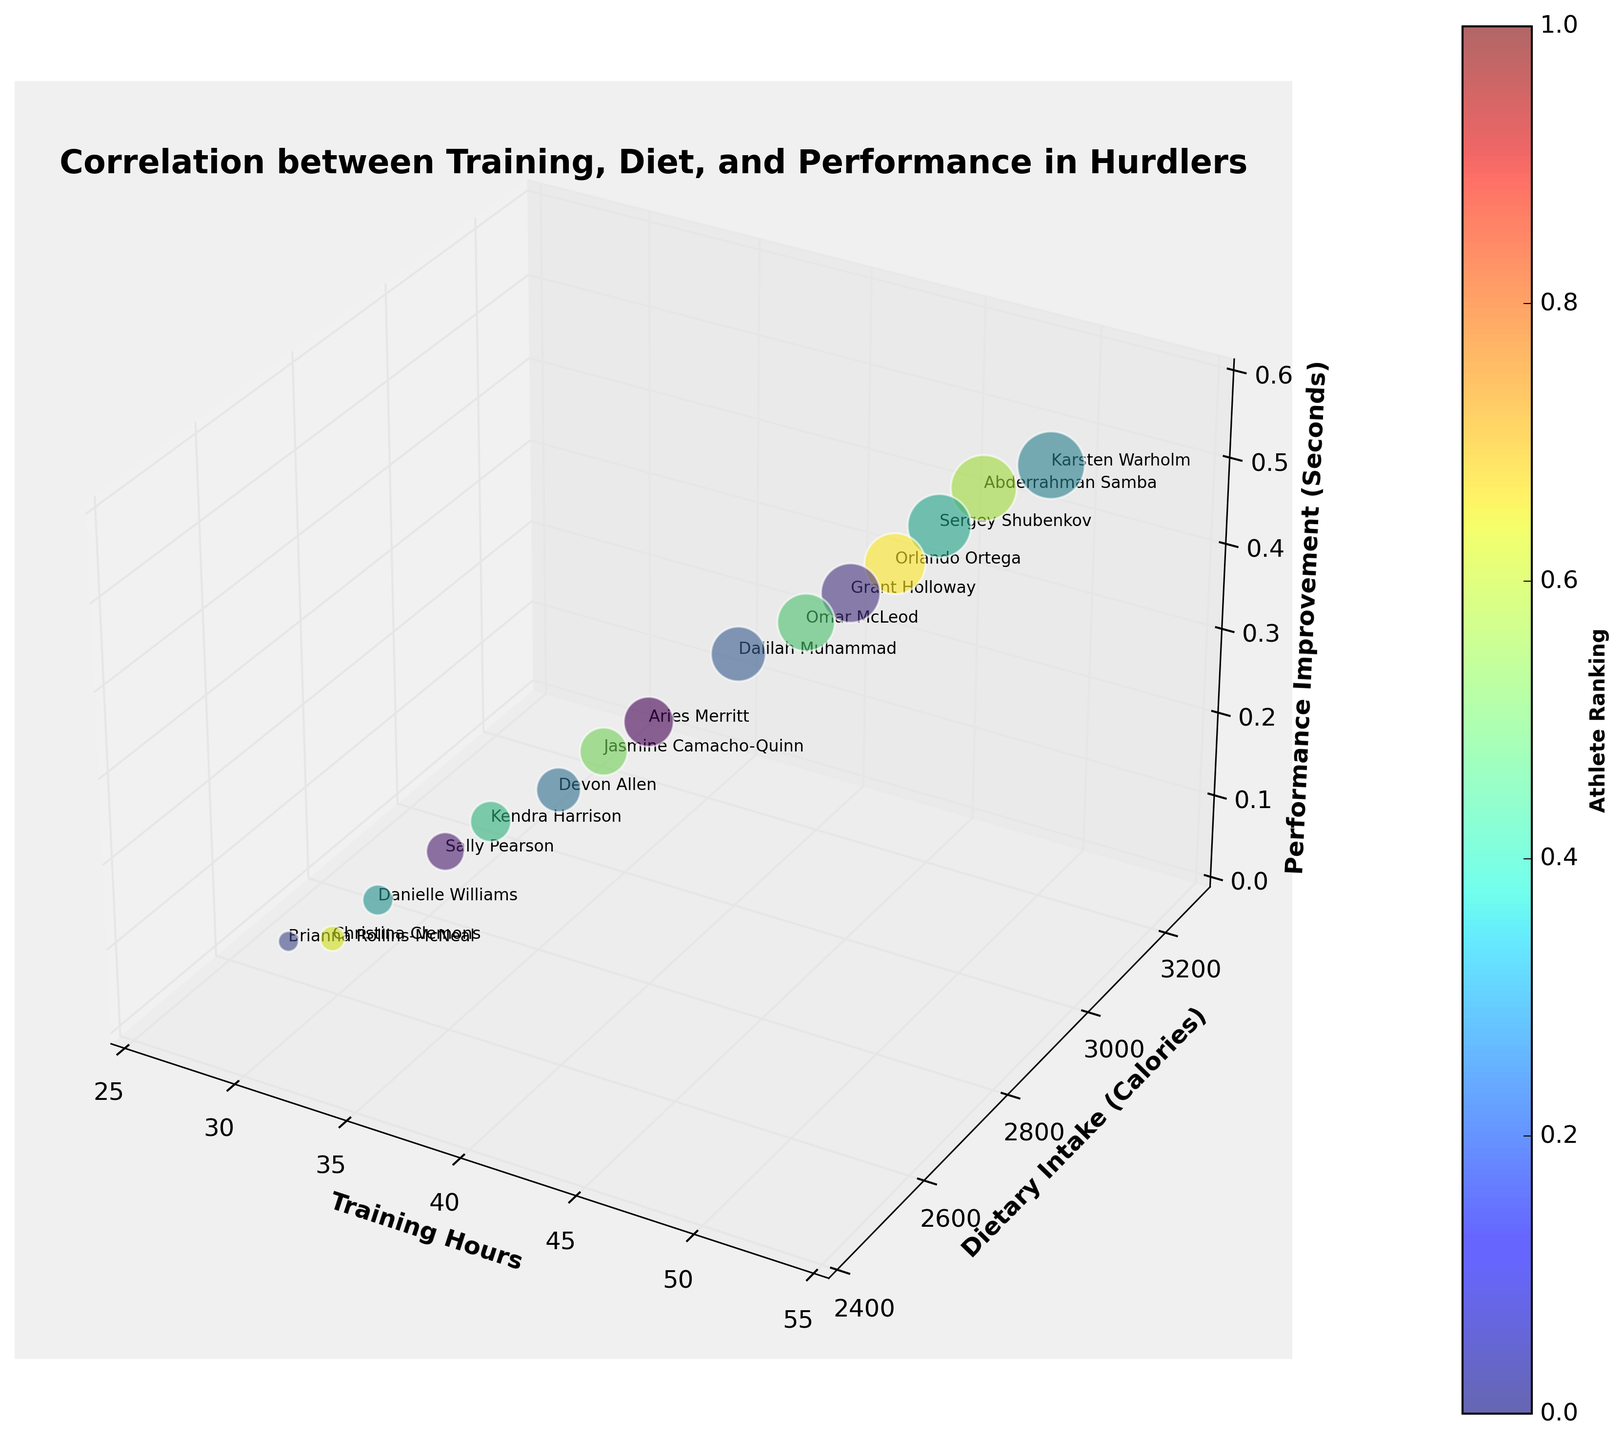What's the title of the figure? The title of the figure is typically located at the top of the plot, and it provides insight into what the graph represents.
Answer: Correlation between Training, Diet, and Performance in Hurdlers How many athletes are represented in the figure? By counting each unique data point or the labels next to each bubble in the plot, we can determine the number of athletes.
Answer: 15 Which athlete trained the highest number of hours? By identifying the bubble that is farthest to the right along the x-axis (Training Hours), we can determine the athlete with the highest training hours.
Answer: Karsten Warholm How does Sergey Shubenkov's dietary intake compare to Abderrahman Samba's? By comparing the y-axis position of Sergey Shubenkov's (3100 Calories) bubble to that of Abderrahman Samba's (3150 Calories), we find that Abderrahman Samba has a slightly higher dietary intake.
Answer: Abderrahman Samba's intake is higher Are there any athletes with the same dietary intake but different training hours? To answer this, we look for bubbles aligned horizontally (same y-axis - Dietary Intake) but positioned differently along the x-axis (Training Hours).
Answer: Yes, Brianna Rollins-McNeal and Christina Clemons both have 2500 Calories Which athlete has shown the best improvement in performance and how many training hours do they have? The best improvement is represented by the highest point along the z-axis (Performance Improvement). The corresponding x-axis value (Training Hours) to this point indicates the training hours.
Answer: Karsten Warholm, 50 hours Does dietary intake appear to have a linear relationship with performance improvement? Observing the alignment of bubbles vertically along the y-axis (Dietary Intake) with respect to the z-axis (Performance Improvement) reveals if there is a consistent pattern.
Answer: No, there's no obvious linear relationship Which athlete has a performance improvement closest to 0.25 seconds? Locate the bubble near the z-axis value of 0.25 (Performance Improvement) and identify the athlete.
Answer: Devon Allen 